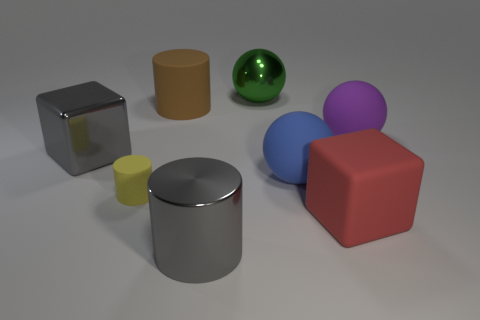Is there a large matte cube that is to the left of the big matte thing in front of the large blue ball?
Your answer should be compact. No. Is the number of tiny brown rubber things less than the number of big purple spheres?
Provide a short and direct response. Yes. There is a cylinder behind the large rubber ball in front of the purple rubber sphere; what is it made of?
Keep it short and to the point. Rubber. Do the shiny cylinder and the green sphere have the same size?
Keep it short and to the point. Yes. How many objects are either big gray metallic cylinders or purple matte balls?
Provide a short and direct response. 2. There is a object that is in front of the tiny matte object and to the right of the large green sphere; what size is it?
Your response must be concise. Large. Are there fewer small objects that are to the right of the purple matte thing than big red matte cubes?
Your response must be concise. Yes. There is a gray thing that is made of the same material as the gray cube; what is its shape?
Offer a terse response. Cylinder. There is a large gray metallic thing on the left side of the large gray metal cylinder; does it have the same shape as the matte thing in front of the yellow cylinder?
Give a very brief answer. Yes. Are there fewer big blue spheres behind the blue matte ball than big cubes in front of the yellow object?
Your answer should be compact. Yes. 